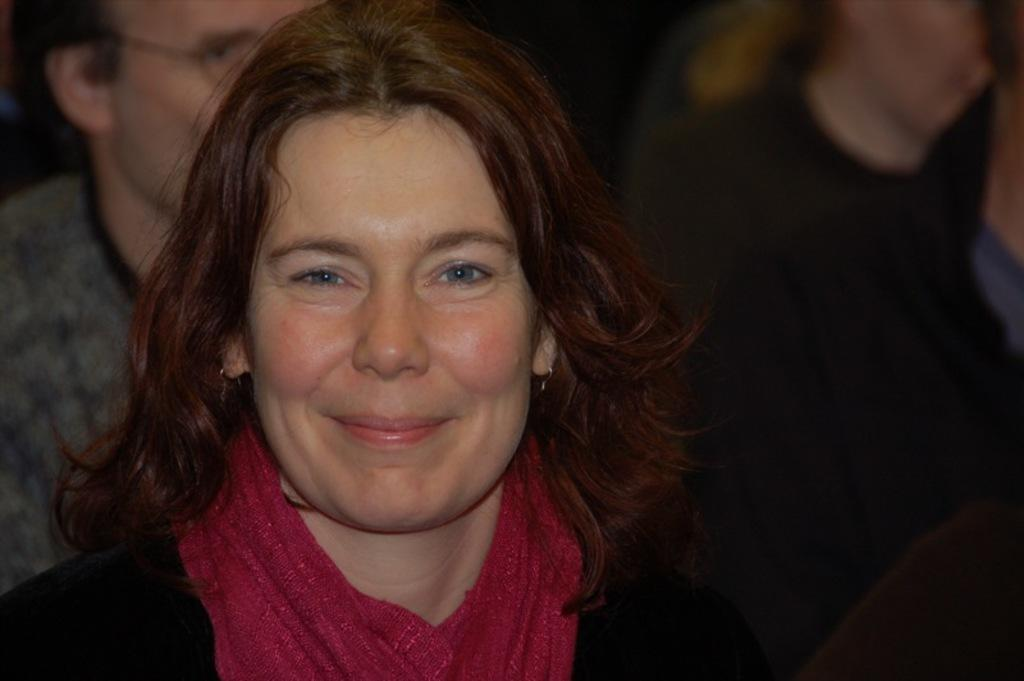What is the main subject in the foreground of the image? There is a woman in the foreground of the image. What is the woman wearing in the image? The woman is wearing a black dress and a red stole. Are there any other people visible in the image? Yes, there are two people in the background of the image. What type of hat is the woman wearing in the image? The woman is not wearing a hat in the image; she is wearing a red stole. Can you describe the body language of the people in the background? There is no information about the body language of the people in the background, as the facts provided do not mention their actions or posture. 